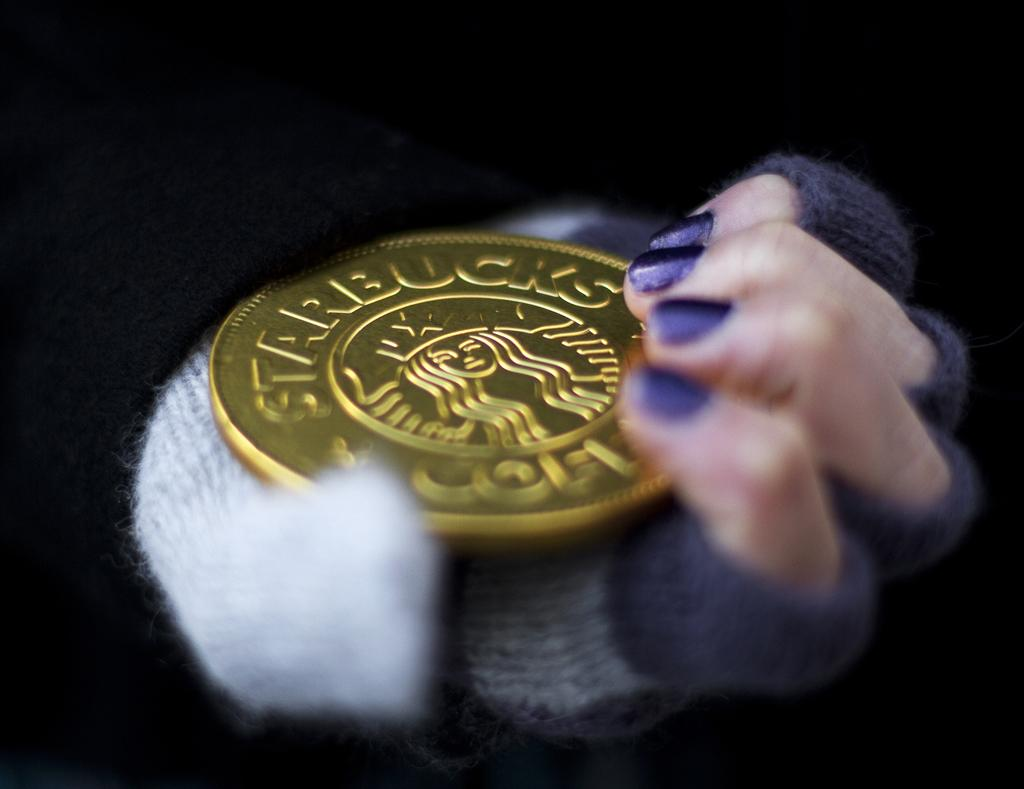Provide a one-sentence caption for the provided image. A big Starbucks coin is held by a hand with purple fingernails. 